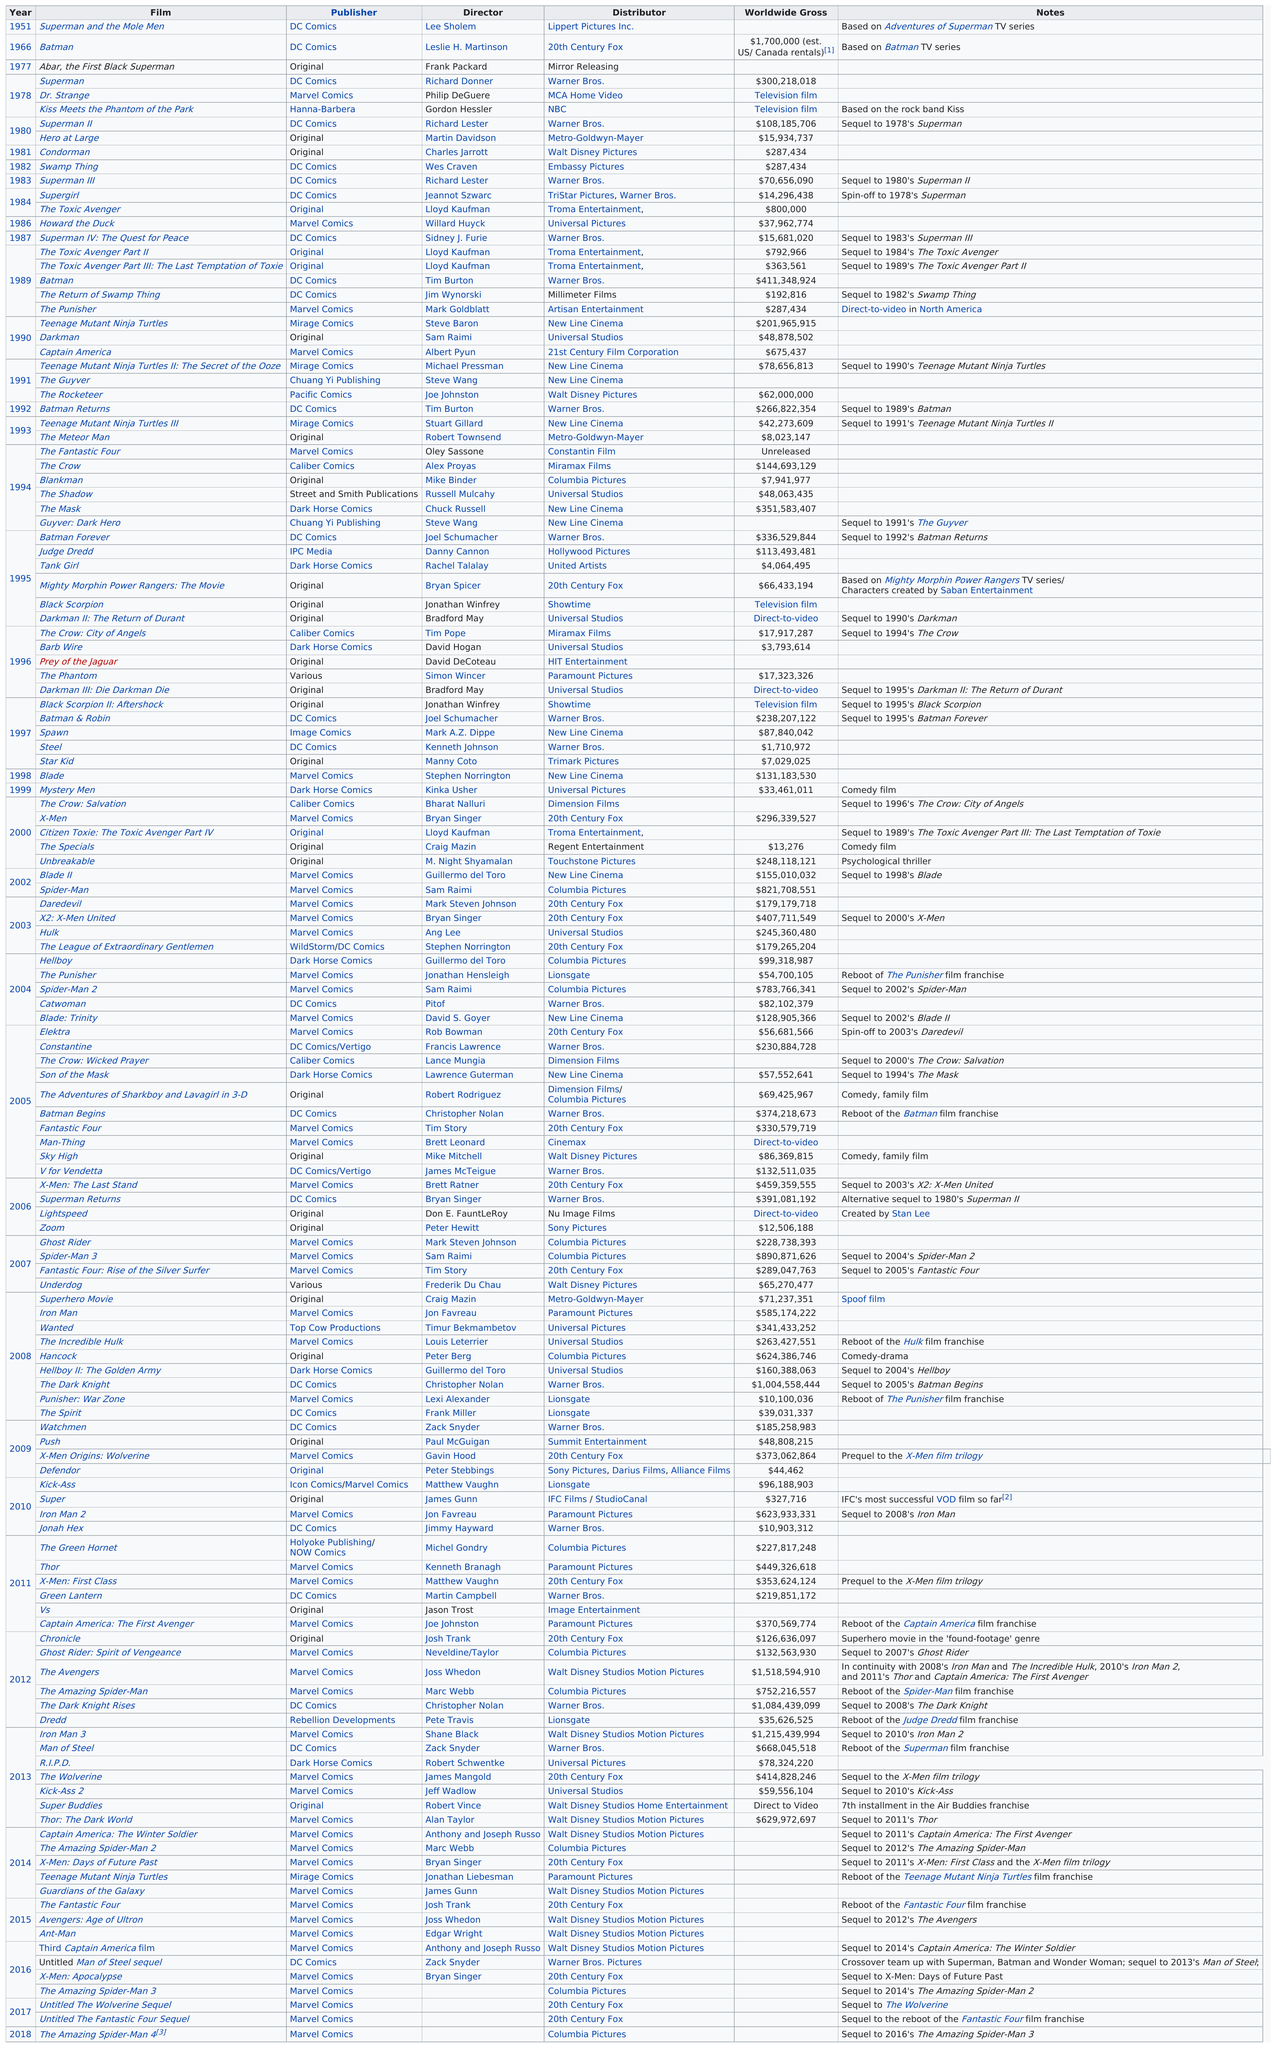Highlight a few significant elements in this photo. Four films are under the publisher Caliber Comics. I, [Your Name], hereby declare that the film titled "The Spirit," published by DC Comics in 2008 and distributed by Lionsgate, grossed over $10,000,000 and meets the specified criteria. In 1978, three live-action American superhero movies were released. The person who directed "The Punisher" is Mark Goldblatt. Superman and the Mole Men, the live-action American superhero movie that was released before the 1966 Batman movie, is known for being one of the earliest examples of the genre. 